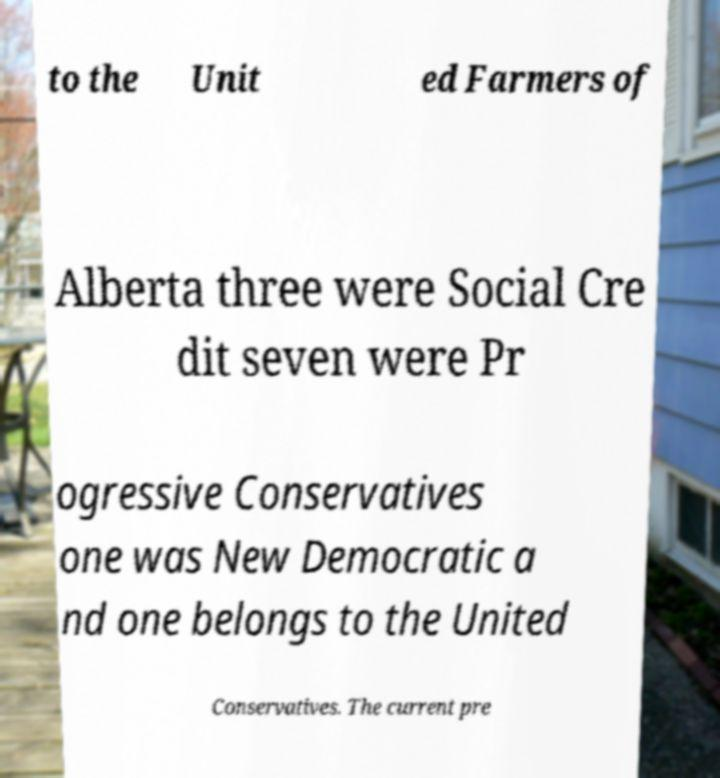I need the written content from this picture converted into text. Can you do that? to the Unit ed Farmers of Alberta three were Social Cre dit seven were Pr ogressive Conservatives one was New Democratic a nd one belongs to the United Conservatives. The current pre 